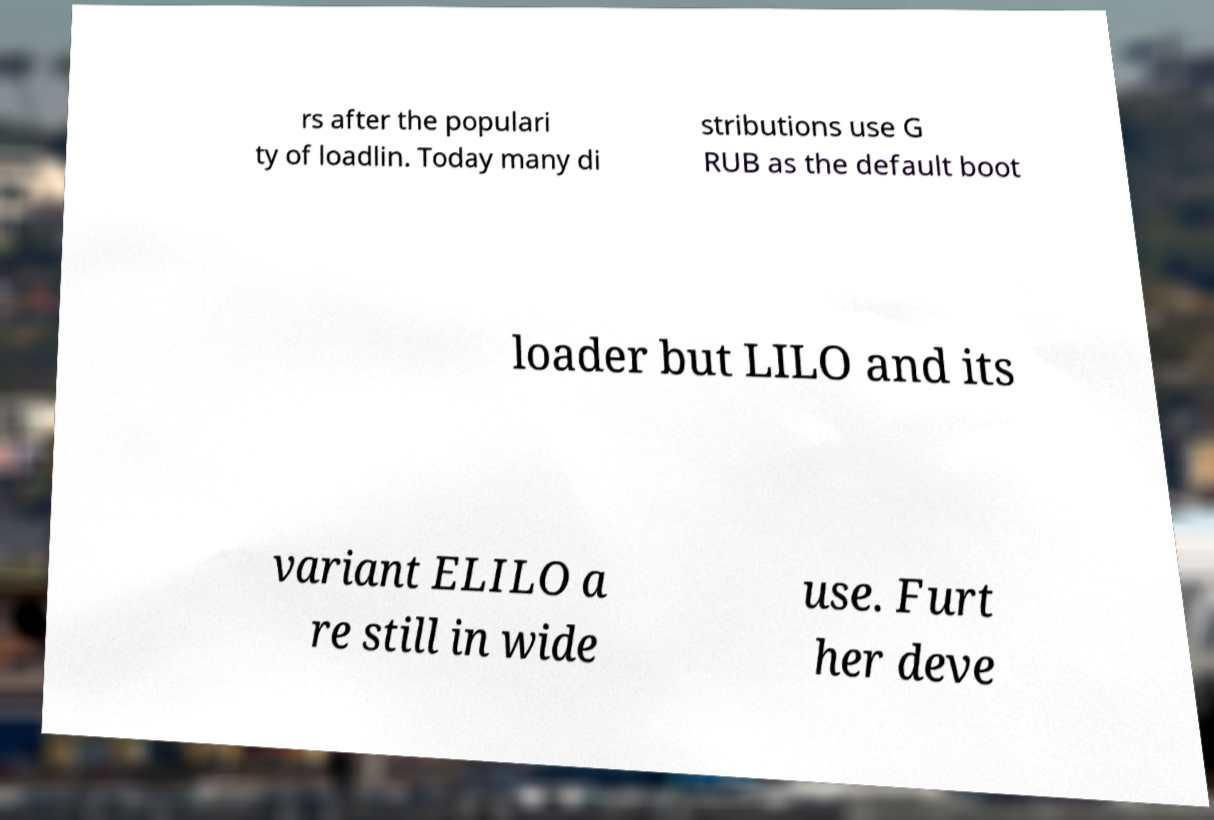What messages or text are displayed in this image? I need them in a readable, typed format. rs after the populari ty of loadlin. Today many di stributions use G RUB as the default boot loader but LILO and its variant ELILO a re still in wide use. Furt her deve 